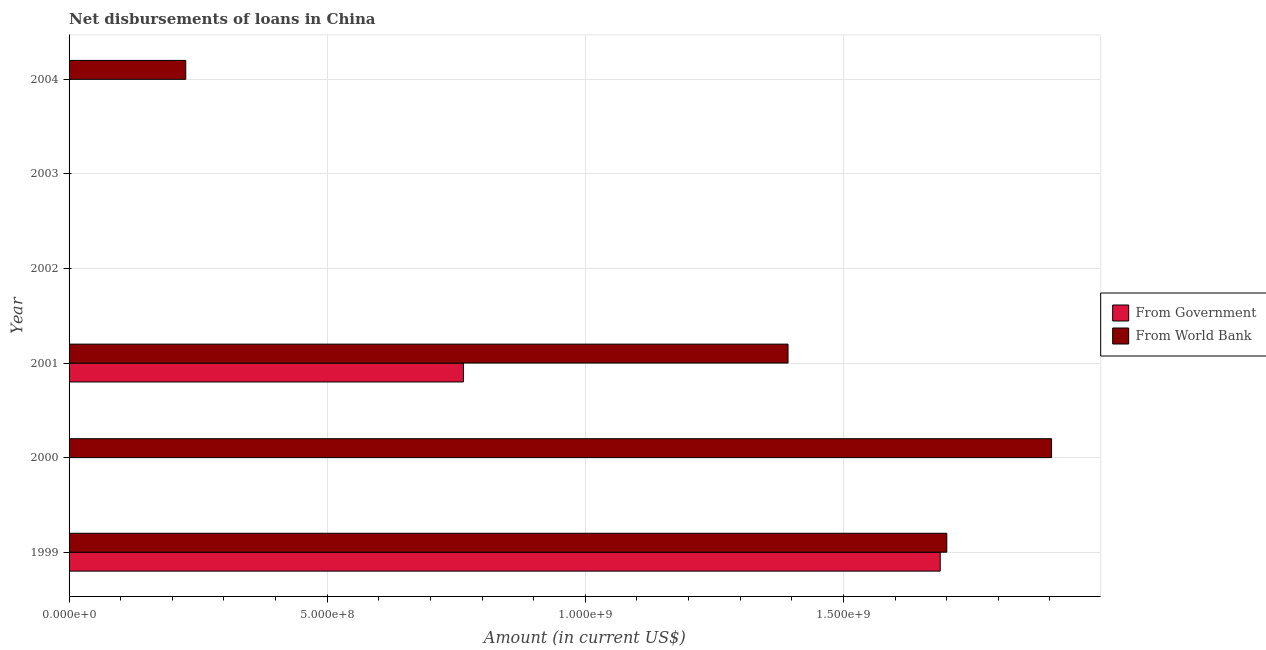How many different coloured bars are there?
Give a very brief answer. 2. Are the number of bars on each tick of the Y-axis equal?
Offer a terse response. No. What is the label of the 4th group of bars from the top?
Offer a very short reply. 2001. What is the net disbursements of loan from government in 2002?
Your answer should be very brief. 0. Across all years, what is the maximum net disbursements of loan from world bank?
Provide a succinct answer. 1.90e+09. Across all years, what is the minimum net disbursements of loan from world bank?
Give a very brief answer. 0. What is the total net disbursements of loan from government in the graph?
Provide a succinct answer. 2.45e+09. What is the difference between the net disbursements of loan from world bank in 1999 and that in 2001?
Provide a succinct answer. 3.08e+08. What is the difference between the net disbursements of loan from government in 2001 and the net disbursements of loan from world bank in 2003?
Your response must be concise. 7.64e+08. What is the average net disbursements of loan from government per year?
Provide a succinct answer. 4.09e+08. In the year 1999, what is the difference between the net disbursements of loan from government and net disbursements of loan from world bank?
Provide a short and direct response. -1.27e+07. What is the ratio of the net disbursements of loan from government in 1999 to that in 2001?
Ensure brevity in your answer.  2.21. What is the difference between the highest and the second highest net disbursements of loan from world bank?
Provide a succinct answer. 2.03e+08. What is the difference between the highest and the lowest net disbursements of loan from world bank?
Ensure brevity in your answer.  1.90e+09. In how many years, is the net disbursements of loan from world bank greater than the average net disbursements of loan from world bank taken over all years?
Your response must be concise. 3. How many bars are there?
Your response must be concise. 6. What is the difference between two consecutive major ticks on the X-axis?
Make the answer very short. 5.00e+08. Are the values on the major ticks of X-axis written in scientific E-notation?
Make the answer very short. Yes. Does the graph contain any zero values?
Your answer should be compact. Yes. Does the graph contain grids?
Ensure brevity in your answer.  Yes. How are the legend labels stacked?
Your answer should be very brief. Vertical. What is the title of the graph?
Your answer should be very brief. Net disbursements of loans in China. Does "Borrowers" appear as one of the legend labels in the graph?
Your response must be concise. No. What is the Amount (in current US$) in From Government in 1999?
Provide a succinct answer. 1.69e+09. What is the Amount (in current US$) in From World Bank in 1999?
Provide a succinct answer. 1.70e+09. What is the Amount (in current US$) in From Government in 2000?
Offer a terse response. 0. What is the Amount (in current US$) of From World Bank in 2000?
Ensure brevity in your answer.  1.90e+09. What is the Amount (in current US$) in From Government in 2001?
Offer a terse response. 7.64e+08. What is the Amount (in current US$) in From World Bank in 2001?
Provide a succinct answer. 1.39e+09. What is the Amount (in current US$) in From Government in 2002?
Provide a short and direct response. 0. What is the Amount (in current US$) in From World Bank in 2003?
Offer a terse response. 0. What is the Amount (in current US$) in From Government in 2004?
Keep it short and to the point. 0. What is the Amount (in current US$) of From World Bank in 2004?
Your answer should be compact. 2.26e+08. Across all years, what is the maximum Amount (in current US$) of From Government?
Give a very brief answer. 1.69e+09. Across all years, what is the maximum Amount (in current US$) of From World Bank?
Offer a terse response. 1.90e+09. What is the total Amount (in current US$) in From Government in the graph?
Provide a short and direct response. 2.45e+09. What is the total Amount (in current US$) in From World Bank in the graph?
Ensure brevity in your answer.  5.22e+09. What is the difference between the Amount (in current US$) in From World Bank in 1999 and that in 2000?
Offer a terse response. -2.03e+08. What is the difference between the Amount (in current US$) of From Government in 1999 and that in 2001?
Your response must be concise. 9.24e+08. What is the difference between the Amount (in current US$) of From World Bank in 1999 and that in 2001?
Your answer should be very brief. 3.08e+08. What is the difference between the Amount (in current US$) of From World Bank in 1999 and that in 2004?
Give a very brief answer. 1.47e+09. What is the difference between the Amount (in current US$) of From World Bank in 2000 and that in 2001?
Make the answer very short. 5.10e+08. What is the difference between the Amount (in current US$) in From World Bank in 2000 and that in 2004?
Make the answer very short. 1.68e+09. What is the difference between the Amount (in current US$) in From World Bank in 2001 and that in 2004?
Offer a very short reply. 1.17e+09. What is the difference between the Amount (in current US$) of From Government in 1999 and the Amount (in current US$) of From World Bank in 2000?
Ensure brevity in your answer.  -2.16e+08. What is the difference between the Amount (in current US$) of From Government in 1999 and the Amount (in current US$) of From World Bank in 2001?
Ensure brevity in your answer.  2.95e+08. What is the difference between the Amount (in current US$) in From Government in 1999 and the Amount (in current US$) in From World Bank in 2004?
Your answer should be very brief. 1.46e+09. What is the difference between the Amount (in current US$) in From Government in 2001 and the Amount (in current US$) in From World Bank in 2004?
Your answer should be very brief. 5.38e+08. What is the average Amount (in current US$) of From Government per year?
Provide a succinct answer. 4.09e+08. What is the average Amount (in current US$) of From World Bank per year?
Your answer should be compact. 8.70e+08. In the year 1999, what is the difference between the Amount (in current US$) in From Government and Amount (in current US$) in From World Bank?
Make the answer very short. -1.27e+07. In the year 2001, what is the difference between the Amount (in current US$) of From Government and Amount (in current US$) of From World Bank?
Keep it short and to the point. -6.29e+08. What is the ratio of the Amount (in current US$) in From World Bank in 1999 to that in 2000?
Provide a short and direct response. 0.89. What is the ratio of the Amount (in current US$) of From Government in 1999 to that in 2001?
Keep it short and to the point. 2.21. What is the ratio of the Amount (in current US$) in From World Bank in 1999 to that in 2001?
Your answer should be very brief. 1.22. What is the ratio of the Amount (in current US$) in From World Bank in 1999 to that in 2004?
Your answer should be very brief. 7.52. What is the ratio of the Amount (in current US$) in From World Bank in 2000 to that in 2001?
Make the answer very short. 1.37. What is the ratio of the Amount (in current US$) of From World Bank in 2000 to that in 2004?
Give a very brief answer. 8.42. What is the ratio of the Amount (in current US$) in From World Bank in 2001 to that in 2004?
Offer a very short reply. 6.16. What is the difference between the highest and the second highest Amount (in current US$) in From World Bank?
Ensure brevity in your answer.  2.03e+08. What is the difference between the highest and the lowest Amount (in current US$) of From Government?
Provide a succinct answer. 1.69e+09. What is the difference between the highest and the lowest Amount (in current US$) of From World Bank?
Give a very brief answer. 1.90e+09. 